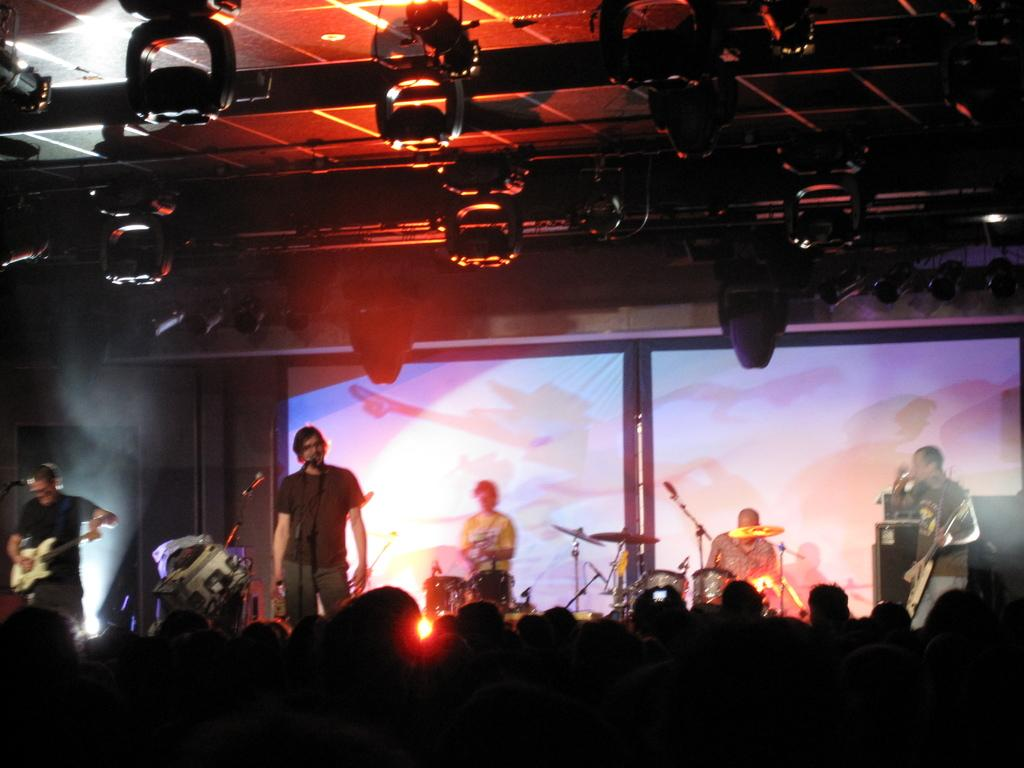What is happening on the stage in the image? There is a music band performing on a stage. What instruments are the band members playing? The band members are playing a guitar and a snare drum. How are the band members communicating with the audience? The band members are singing on a microphone. Are there any spectators present in the image? Yes, there is an audience present. What type of robin can be seen teaching the audience about the voyage in the image? There is no robin or voyage present in the image; it features a music band performing on a stage. 